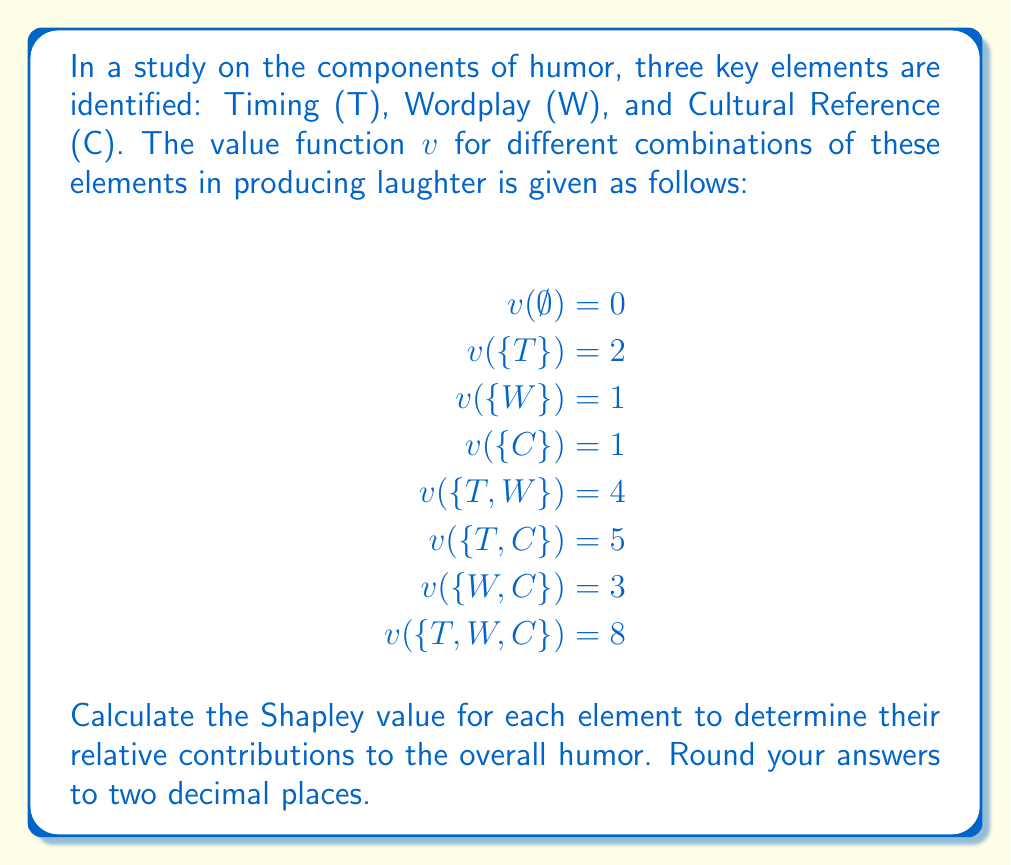Show me your answer to this math problem. To calculate the Shapley value, we need to consider all possible coalitions and the marginal contributions of each element. The Shapley value for player $i$ is given by:

$$\phi_i(v) = \sum_{S \subseteq N \setminus \{i\}} \frac{|S|!(n-|S|-1)!}{n!}[v(S \cup \{i\}) - v(S)]$$

Where $N$ is the set of all players, $n$ is the total number of players, and $S$ is a subset of $N$ not containing player $i$.

Let's calculate for each element:

1. Timing (T):
   $\phi_T = \frac{1}{3}[v(\{T\}) - v(\emptyset)] + \frac{1}{6}[v(\{T,W\}) - v(\{W\})] + \frac{1}{6}[v(\{T,C\}) - v(\{C\})] + \frac{1}{3}[v(\{T,W,C\}) - v(\{W,C\})]$
   $\phi_T = \frac{1}{3}(2-0) + \frac{1}{6}(4-1) + \frac{1}{6}(5-1) + \frac{1}{3}(8-3)$
   $\phi_T = \frac{2}{3} + \frac{1}{2} + \frac{2}{3} + \frac{5}{3} = 3.5$

2. Wordplay (W):
   $\phi_W = \frac{1}{3}[v(\{W\}) - v(\emptyset)] + \frac{1}{6}[v(\{T,W\}) - v(\{T\})] + \frac{1}{6}[v(\{W,C\}) - v(\{C\})] + \frac{1}{3}[v(\{T,W,C\}) - v(\{T,C\})]$
   $\phi_W = \frac{1}{3}(1-0) + \frac{1}{6}(4-2) + \frac{1}{6}(3-1) + \frac{1}{3}(8-5)$
   $\phi_W = \frac{1}{3} + \frac{1}{3} + \frac{1}{3} + 1 = 2$

3. Cultural Reference (C):
   $\phi_C = \frac{1}{3}[v(\{C\}) - v(\emptyset)] + \frac{1}{6}[v(\{T,C\}) - v(\{T\})] + \frac{1}{6}[v(\{W,C\}) - v(\{W\})] + \frac{1}{3}[v(\{T,W,C\}) - v(\{T,W\})]$
   $\phi_C = \frac{1}{3}(1-0) + \frac{1}{6}(5-2) + \frac{1}{6}(3-1) + \frac{1}{3}(8-4)$
   $\phi_C = \frac{1}{3} + \frac{1}{2} + \frac{1}{3} + \frac{4}{3} = 2.5$
Answer: The Shapley values for each element are:
Timing (T): 3.50
Wordplay (W): 2.00
Cultural Reference (C): 2.50 